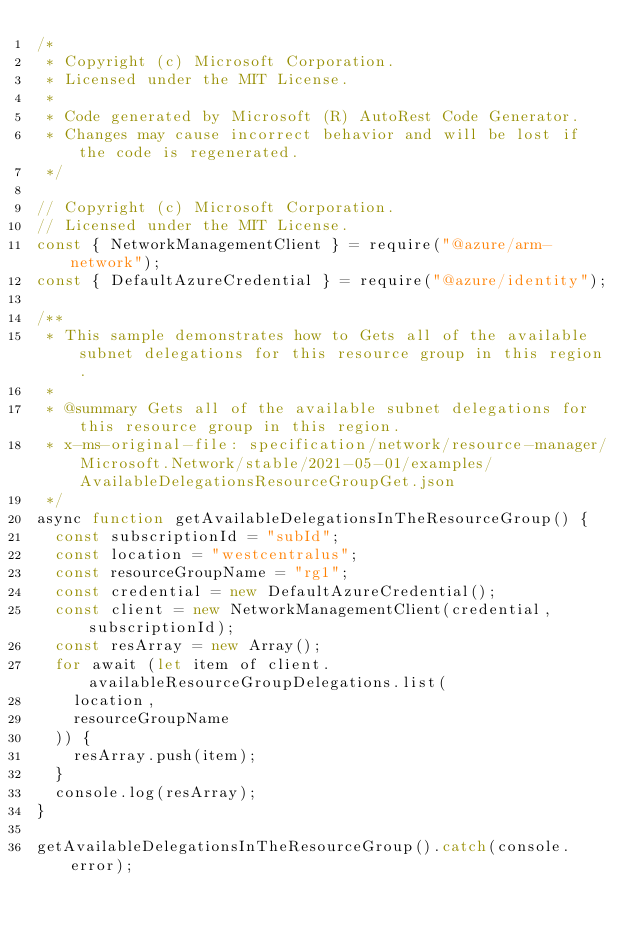Convert code to text. <code><loc_0><loc_0><loc_500><loc_500><_JavaScript_>/*
 * Copyright (c) Microsoft Corporation.
 * Licensed under the MIT License.
 *
 * Code generated by Microsoft (R) AutoRest Code Generator.
 * Changes may cause incorrect behavior and will be lost if the code is regenerated.
 */

// Copyright (c) Microsoft Corporation.
// Licensed under the MIT License.
const { NetworkManagementClient } = require("@azure/arm-network");
const { DefaultAzureCredential } = require("@azure/identity");

/**
 * This sample demonstrates how to Gets all of the available subnet delegations for this resource group in this region.
 *
 * @summary Gets all of the available subnet delegations for this resource group in this region.
 * x-ms-original-file: specification/network/resource-manager/Microsoft.Network/stable/2021-05-01/examples/AvailableDelegationsResourceGroupGet.json
 */
async function getAvailableDelegationsInTheResourceGroup() {
  const subscriptionId = "subId";
  const location = "westcentralus";
  const resourceGroupName = "rg1";
  const credential = new DefaultAzureCredential();
  const client = new NetworkManagementClient(credential, subscriptionId);
  const resArray = new Array();
  for await (let item of client.availableResourceGroupDelegations.list(
    location,
    resourceGroupName
  )) {
    resArray.push(item);
  }
  console.log(resArray);
}

getAvailableDelegationsInTheResourceGroup().catch(console.error);
</code> 